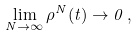<formula> <loc_0><loc_0><loc_500><loc_500>\lim _ { N \to \infty } \rho ^ { N } ( t ) \to 0 \, ,</formula> 